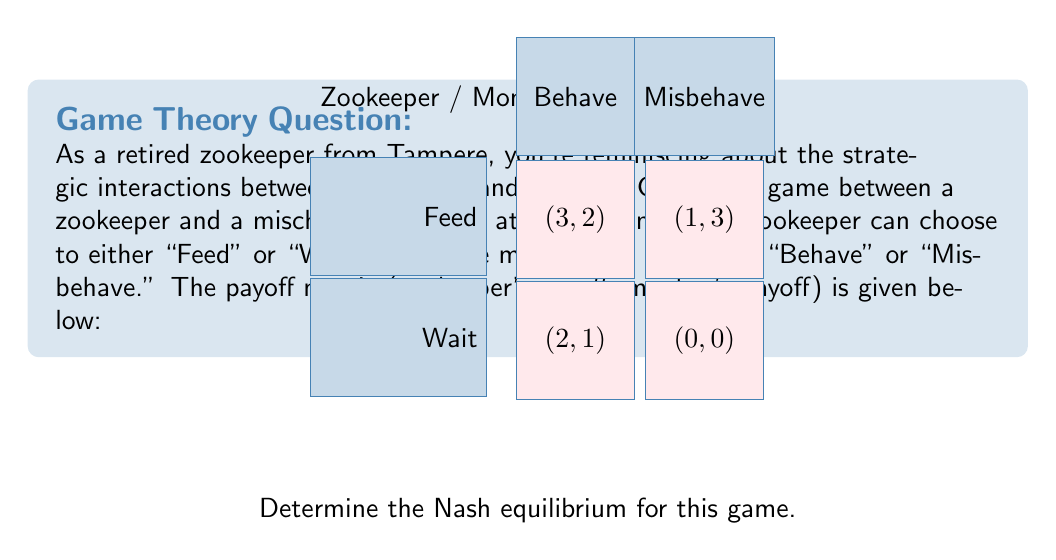Show me your answer to this math problem. To find the Nash equilibrium, we need to identify the strategy pairs where neither player has an incentive to unilaterally change their strategy. Let's analyze each player's best responses:

1. Zookeeper's perspective:
   - If Monkey Behaves: Feed (3) > Wait (2)
   - If Monkey Misbehaves: Feed (1) > Wait (0)
   The zookeeper's dominant strategy is to Feed.

2. Monkey's perspective:
   - If Zookeeper Feeds: Behave (2) < Misbehave (3)
   - If Zookeeper Waits: Behave (1) > Misbehave (0)
   The monkey doesn't have a dominant strategy.

3. Given that the zookeeper will always choose to Feed (dominant strategy), the monkey's best response is to Misbehave (3 > 2).

4. Now, let's check if (Feed, Misbehave) is a Nash equilibrium:
   - Zookeeper: Cannot improve by switching to Wait (1 > 0)
   - Monkey: Cannot improve by switching to Behave (2 < 3)

Therefore, the Nash equilibrium is (Feed, Misbehave) with payoffs (1, 3).

This equilibrium reflects a common challenge in animal care: even when animals misbehave, keepers often must continue to feed them for their well-being, which can inadvertently reinforce the misbehavior.
Answer: (Feed, Misbehave) 